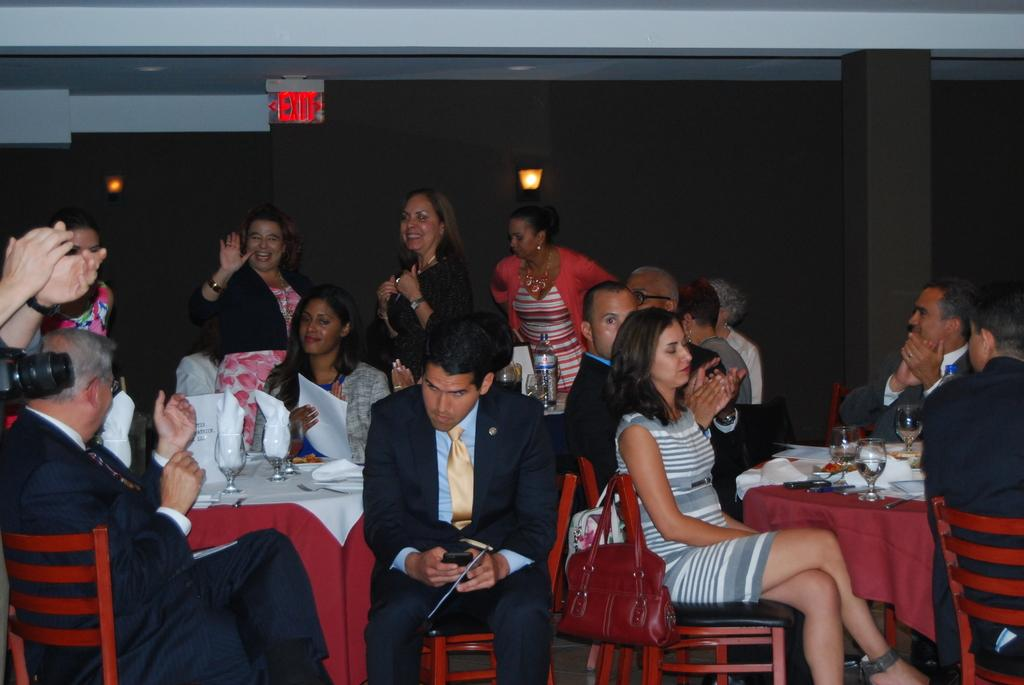<image>
Write a terse but informative summary of the picture. A large group of people are seated at the tables and applauding while an exit sign is lit red above. 